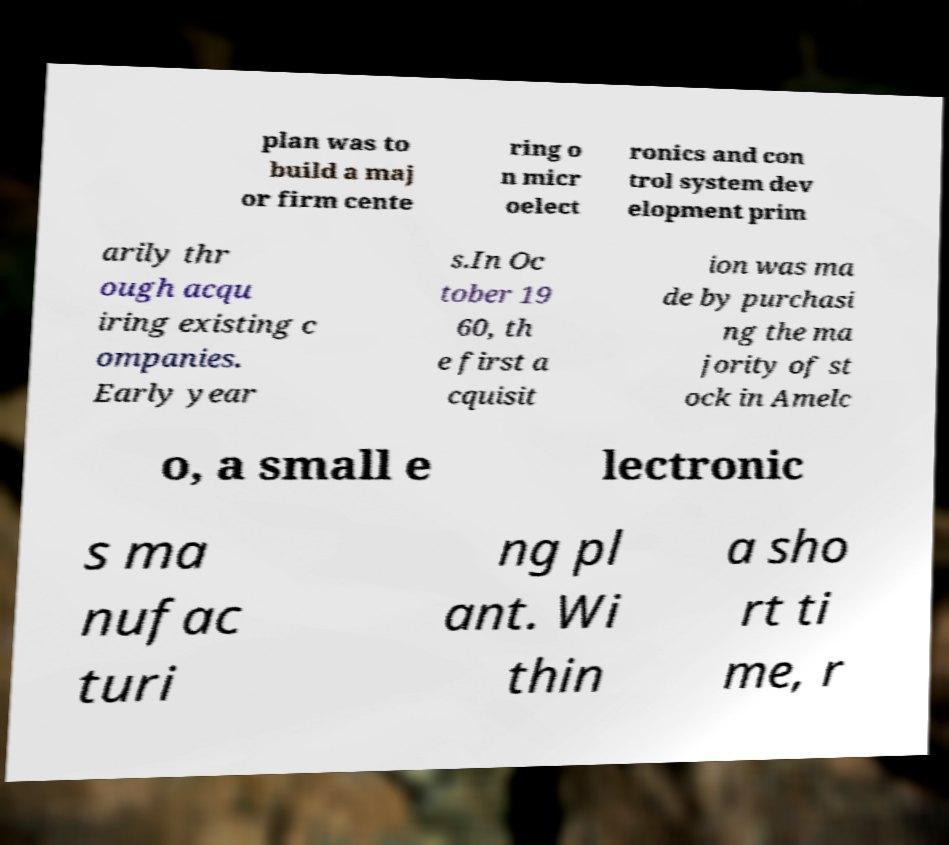Could you assist in decoding the text presented in this image and type it out clearly? plan was to build a maj or firm cente ring o n micr oelect ronics and con trol system dev elopment prim arily thr ough acqu iring existing c ompanies. Early year s.In Oc tober 19 60, th e first a cquisit ion was ma de by purchasi ng the ma jority of st ock in Amelc o, a small e lectronic s ma nufac turi ng pl ant. Wi thin a sho rt ti me, r 